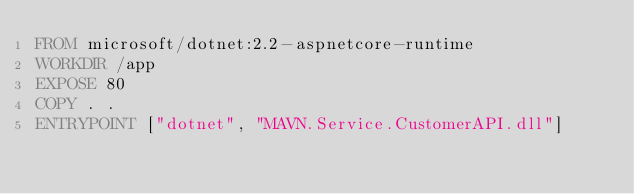Convert code to text. <code><loc_0><loc_0><loc_500><loc_500><_Dockerfile_>FROM microsoft/dotnet:2.2-aspnetcore-runtime
WORKDIR /app
EXPOSE 80
COPY . .
ENTRYPOINT ["dotnet", "MAVN.Service.CustomerAPI.dll"]
</code> 